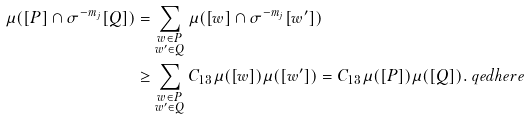<formula> <loc_0><loc_0><loc_500><loc_500>\mu ( [ P ] \cap \sigma ^ { - m _ { j } } [ Q ] ) & = \sum _ { \substack { w \in P \\ w ^ { \prime } \in Q } } \mu ( [ w ] \cap \sigma ^ { - m _ { j } } [ w ^ { \prime } ] ) \\ & \geq \sum _ { \substack { w \in P \\ w ^ { \prime } \in Q } } C _ { 1 3 } \mu ( [ w ] ) \mu ( [ w ^ { \prime } ] ) = C _ { 1 3 } \mu ( [ P ] ) \mu ( [ Q ] ) . \ q e d h e r e</formula> 